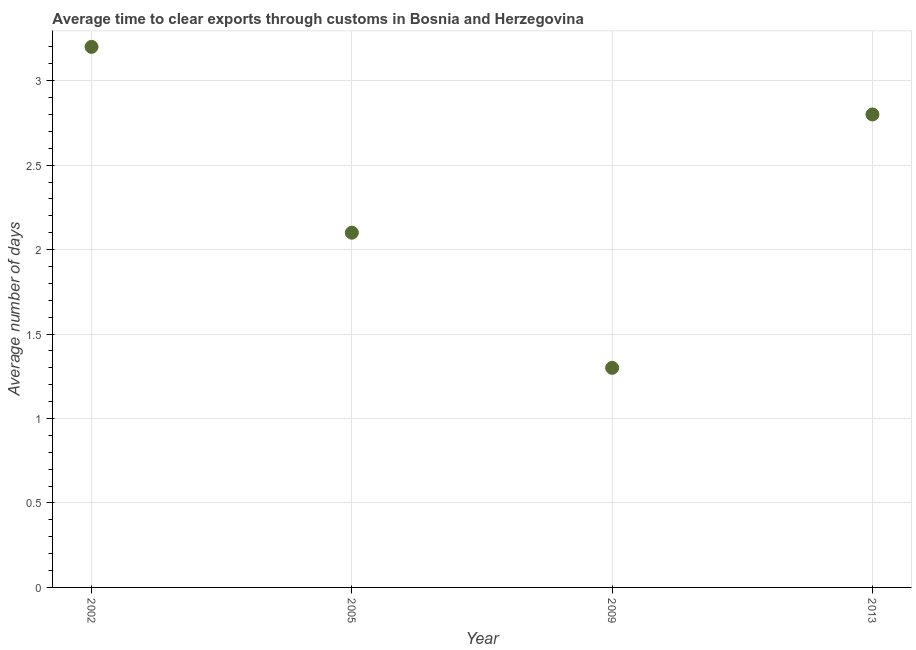What is the time to clear exports through customs in 2013?
Make the answer very short. 2.8. Across all years, what is the maximum time to clear exports through customs?
Offer a terse response. 3.2. Across all years, what is the minimum time to clear exports through customs?
Give a very brief answer. 1.3. In which year was the time to clear exports through customs minimum?
Provide a short and direct response. 2009. What is the difference between the time to clear exports through customs in 2002 and 2009?
Offer a terse response. 1.9. What is the average time to clear exports through customs per year?
Provide a short and direct response. 2.35. What is the median time to clear exports through customs?
Your answer should be compact. 2.45. What is the ratio of the time to clear exports through customs in 2002 to that in 2013?
Provide a short and direct response. 1.14. Is the time to clear exports through customs in 2002 less than that in 2009?
Provide a short and direct response. No. What is the difference between the highest and the second highest time to clear exports through customs?
Provide a short and direct response. 0.4. What is the difference between the highest and the lowest time to clear exports through customs?
Provide a succinct answer. 1.9. Are the values on the major ticks of Y-axis written in scientific E-notation?
Provide a succinct answer. No. Does the graph contain any zero values?
Give a very brief answer. No. What is the title of the graph?
Offer a terse response. Average time to clear exports through customs in Bosnia and Herzegovina. What is the label or title of the X-axis?
Offer a terse response. Year. What is the label or title of the Y-axis?
Give a very brief answer. Average number of days. What is the Average number of days in 2002?
Keep it short and to the point. 3.2. What is the Average number of days in 2009?
Give a very brief answer. 1.3. What is the difference between the Average number of days in 2005 and 2009?
Keep it short and to the point. 0.8. What is the difference between the Average number of days in 2005 and 2013?
Provide a short and direct response. -0.7. What is the difference between the Average number of days in 2009 and 2013?
Your answer should be compact. -1.5. What is the ratio of the Average number of days in 2002 to that in 2005?
Make the answer very short. 1.52. What is the ratio of the Average number of days in 2002 to that in 2009?
Give a very brief answer. 2.46. What is the ratio of the Average number of days in 2002 to that in 2013?
Ensure brevity in your answer.  1.14. What is the ratio of the Average number of days in 2005 to that in 2009?
Your response must be concise. 1.61. What is the ratio of the Average number of days in 2009 to that in 2013?
Make the answer very short. 0.46. 